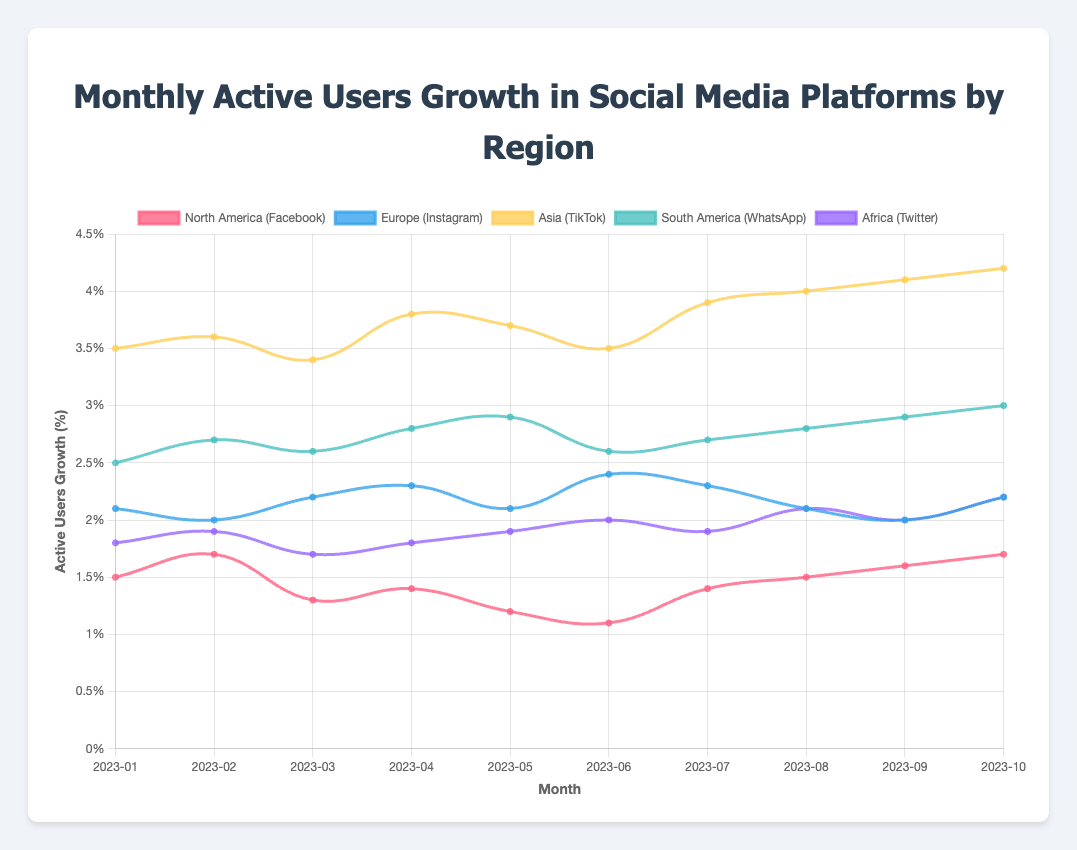Which platform in which region had the highest monthly active users growth in October 2023? First, identify the ActiveUsersGrowth value for each platform in each region for October 2023. TikTok in Asia has the highest growth at 4.2%.
Answer: TikTok in Asia What is the difference in the growth rate between TikTok in Asia and Twitter in Africa for January 2023? Look at the ActiveUsersGrowth for January 2023 for both TikTok in Asia (3.5%) and Twitter in Africa (1.8%), then compute the difference 3.5% - 1.8%.
Answer: 1.7% Which social media platform had a decreasing trend in growth from January to June 2023 in North America? Examine the ActiveUsersGrowth values for Facebook in North America from January (1.5%) to June (1.1%) and confirm that the values are decreasing or fluctuating downward.
Answer: Facebook What is the average monthly active users growth for Instagram in Europe for the months of March, April, and May 2023? Add the ActiveUsersGrowth values for March (2.2%), April (2.3%), and May (2.1%) and divide by 3 to find the average. Therefore, (2.2 + 2.3 + 2.1) / 3 = 2.2%.
Answer: 2.2% Between WhatsApp in South America and Twitter in Africa, which had higher growth in July 2023? Compare the ActiveUsersGrowth of WhatsApp in South America (2.7%) and Twitter in Africa (1.9%) for July 2023 to determine which is higher.
Answer: WhatsApp in South America Identify the month with the lowest growth rate for Facebook in North America in 2023. Check the ActiveUsersGrowth values for Facebook in North America for each month and find that June (1.1%) has the lowest growth rate.
Answer: June Calculate the total growth in percentage points for TikTok in Asia from August to October 2023. Sum the ActiveUsersGrowth values for TikTok in Asia for August (4.0%), September (4.1%), and October (4.2%), resulting in a total of 4.0% + 4.1% + 4.2% = 12.3%.
Answer: 12.3% Did any platform in Africa experience a growth rate of 2.0% at any point in 2023? Check ActiveUsersGrowth for Twitter in Africa across all months of 2023 and find yes, in June 2023 the growth rate was exactly 2.0%.
Answer: Yes What was the visual color representation used for Instagram in Europe? The visual attributes indicate that Instagram in Europe used a color code corresponding to 'blue'.
Answer: Blue Which platform achieved a consistent increase in growth rate for three consecutive months? Inspect all growth rates and find that TikTok in Asia had a consistent increase from January to February (3.5% to 3.6%), from March to April (3.4% to 3.8%), and from August to October (4.0% to 4.2%).
Answer: TikTok in Asia 